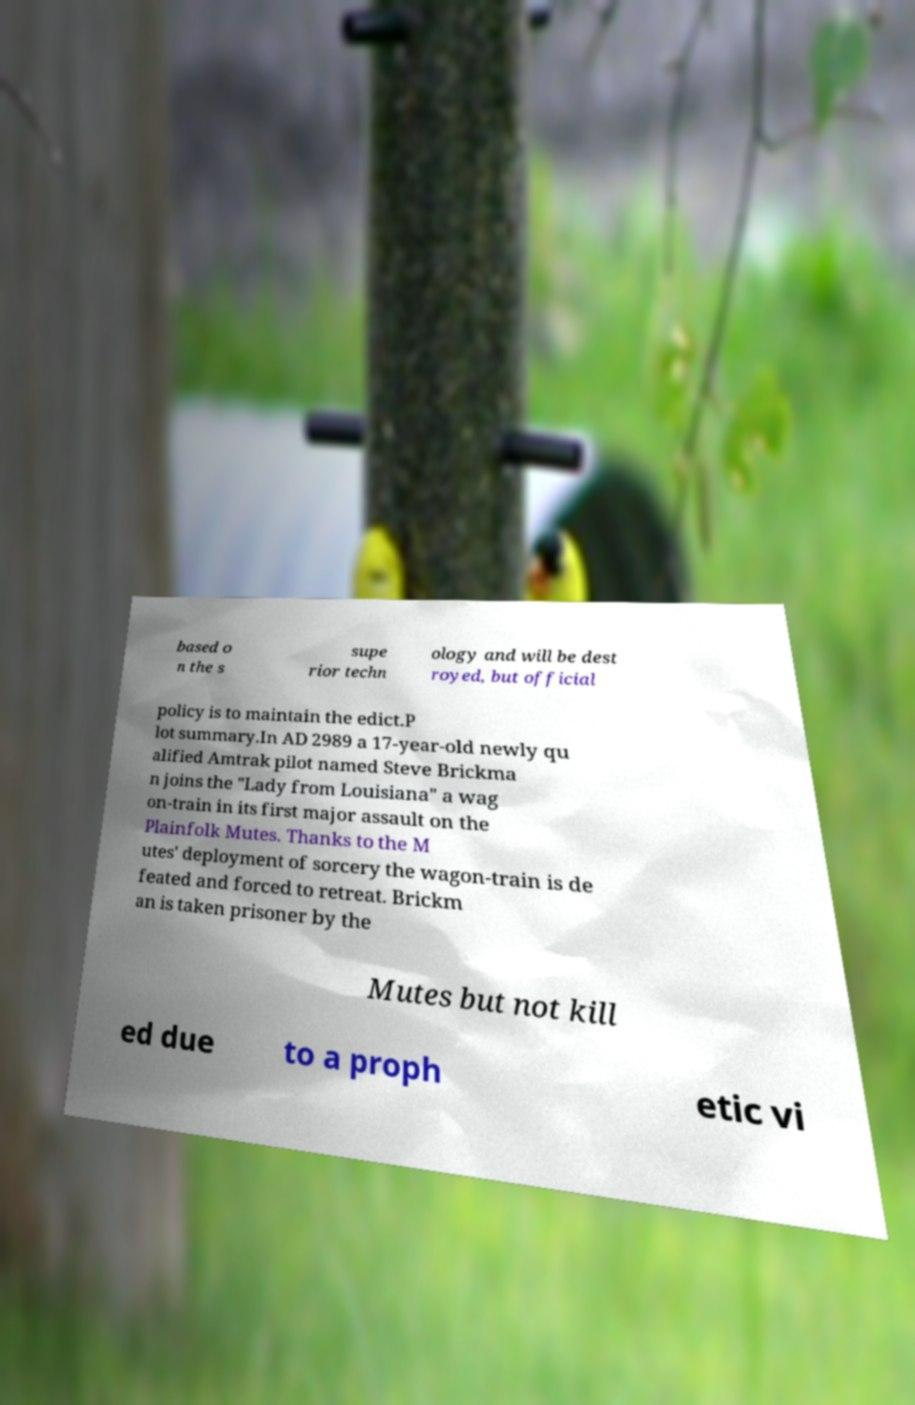Can you accurately transcribe the text from the provided image for me? based o n the s supe rior techn ology and will be dest royed, but official policy is to maintain the edict.P lot summary.In AD 2989 a 17-year-old newly qu alified Amtrak pilot named Steve Brickma n joins the "Lady from Louisiana" a wag on-train in its first major assault on the Plainfolk Mutes. Thanks to the M utes' deployment of sorcery the wagon-train is de feated and forced to retreat. Brickm an is taken prisoner by the Mutes but not kill ed due to a proph etic vi 